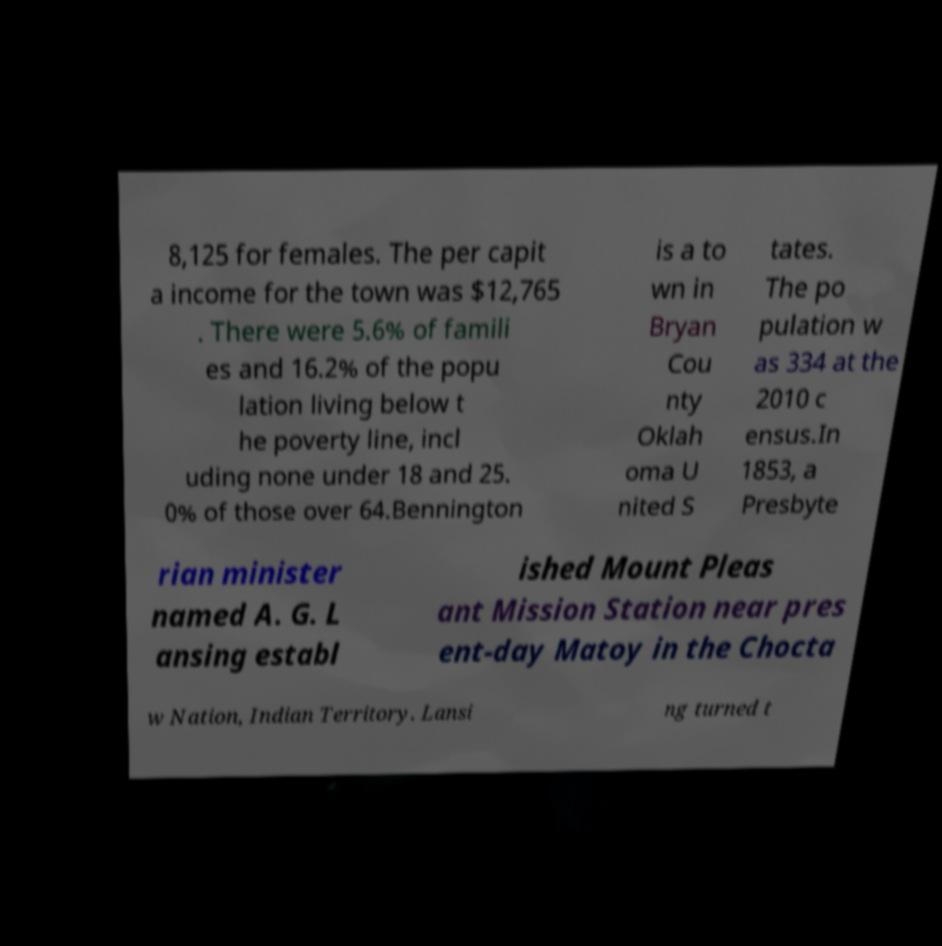Could you assist in decoding the text presented in this image and type it out clearly? 8,125 for females. The per capit a income for the town was $12,765 . There were 5.6% of famili es and 16.2% of the popu lation living below t he poverty line, incl uding none under 18 and 25. 0% of those over 64.Bennington is a to wn in Bryan Cou nty Oklah oma U nited S tates. The po pulation w as 334 at the 2010 c ensus.In 1853, a Presbyte rian minister named A. G. L ansing establ ished Mount Pleas ant Mission Station near pres ent-day Matoy in the Chocta w Nation, Indian Territory. Lansi ng turned t 